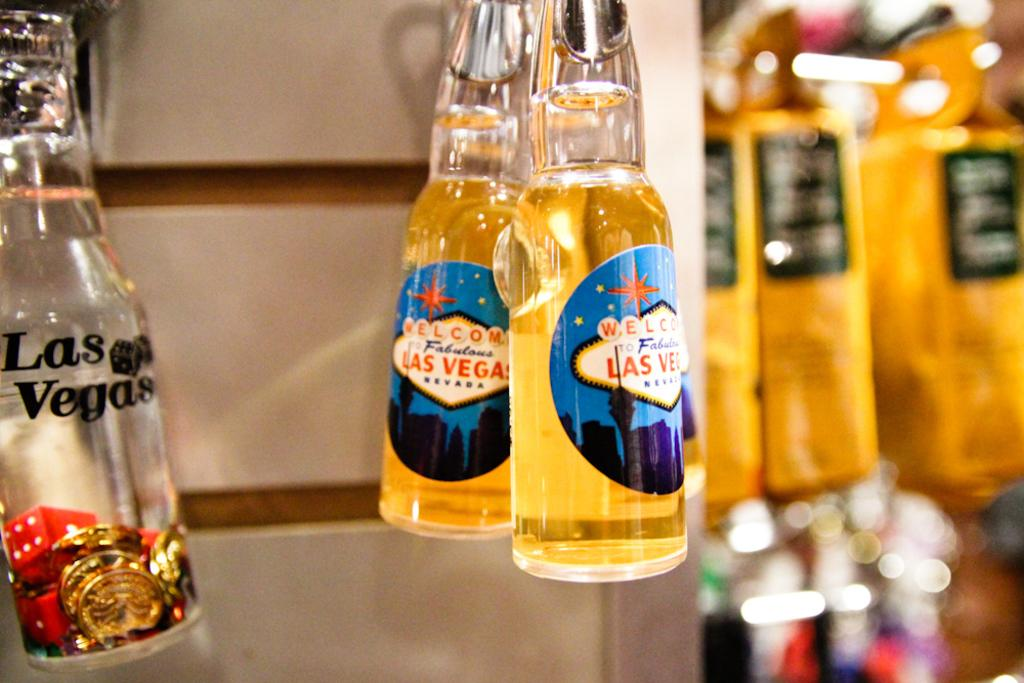<image>
Offer a succinct explanation of the picture presented. Several bottles with the words Las Vegas on them 